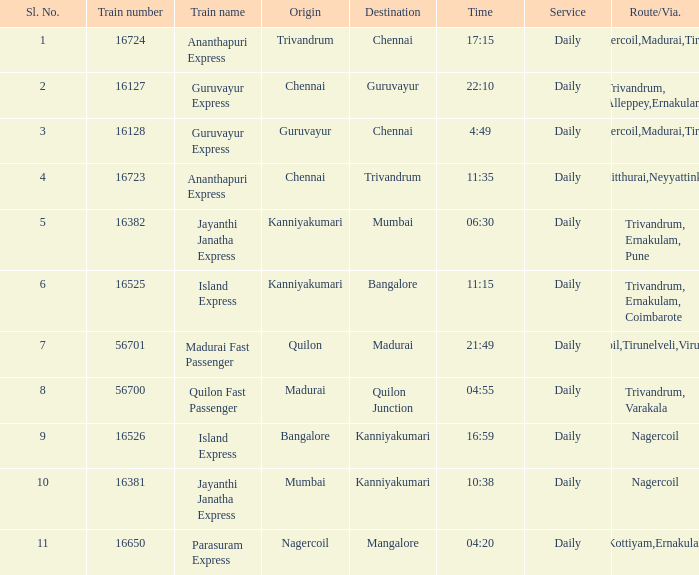What is the route/via when the destination is listed as Madurai? Nagercoil,Tirunelveli,Virudunagar. 